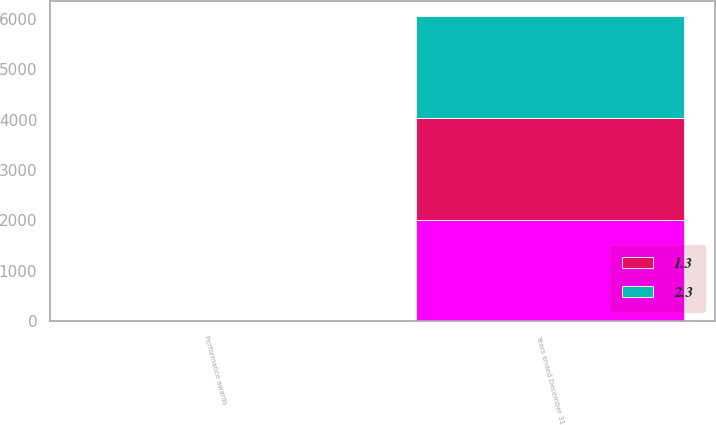Convert chart to OTSL. <chart><loc_0><loc_0><loc_500><loc_500><stacked_bar_chart><ecel><fcel>Years ended December 31<fcel>Performance awards<nl><fcel>nan<fcel>2015<fcel>5.6<nl><fcel>1.3<fcel>2014<fcel>5.1<nl><fcel>2.3<fcel>2013<fcel>4.2<nl></chart> 